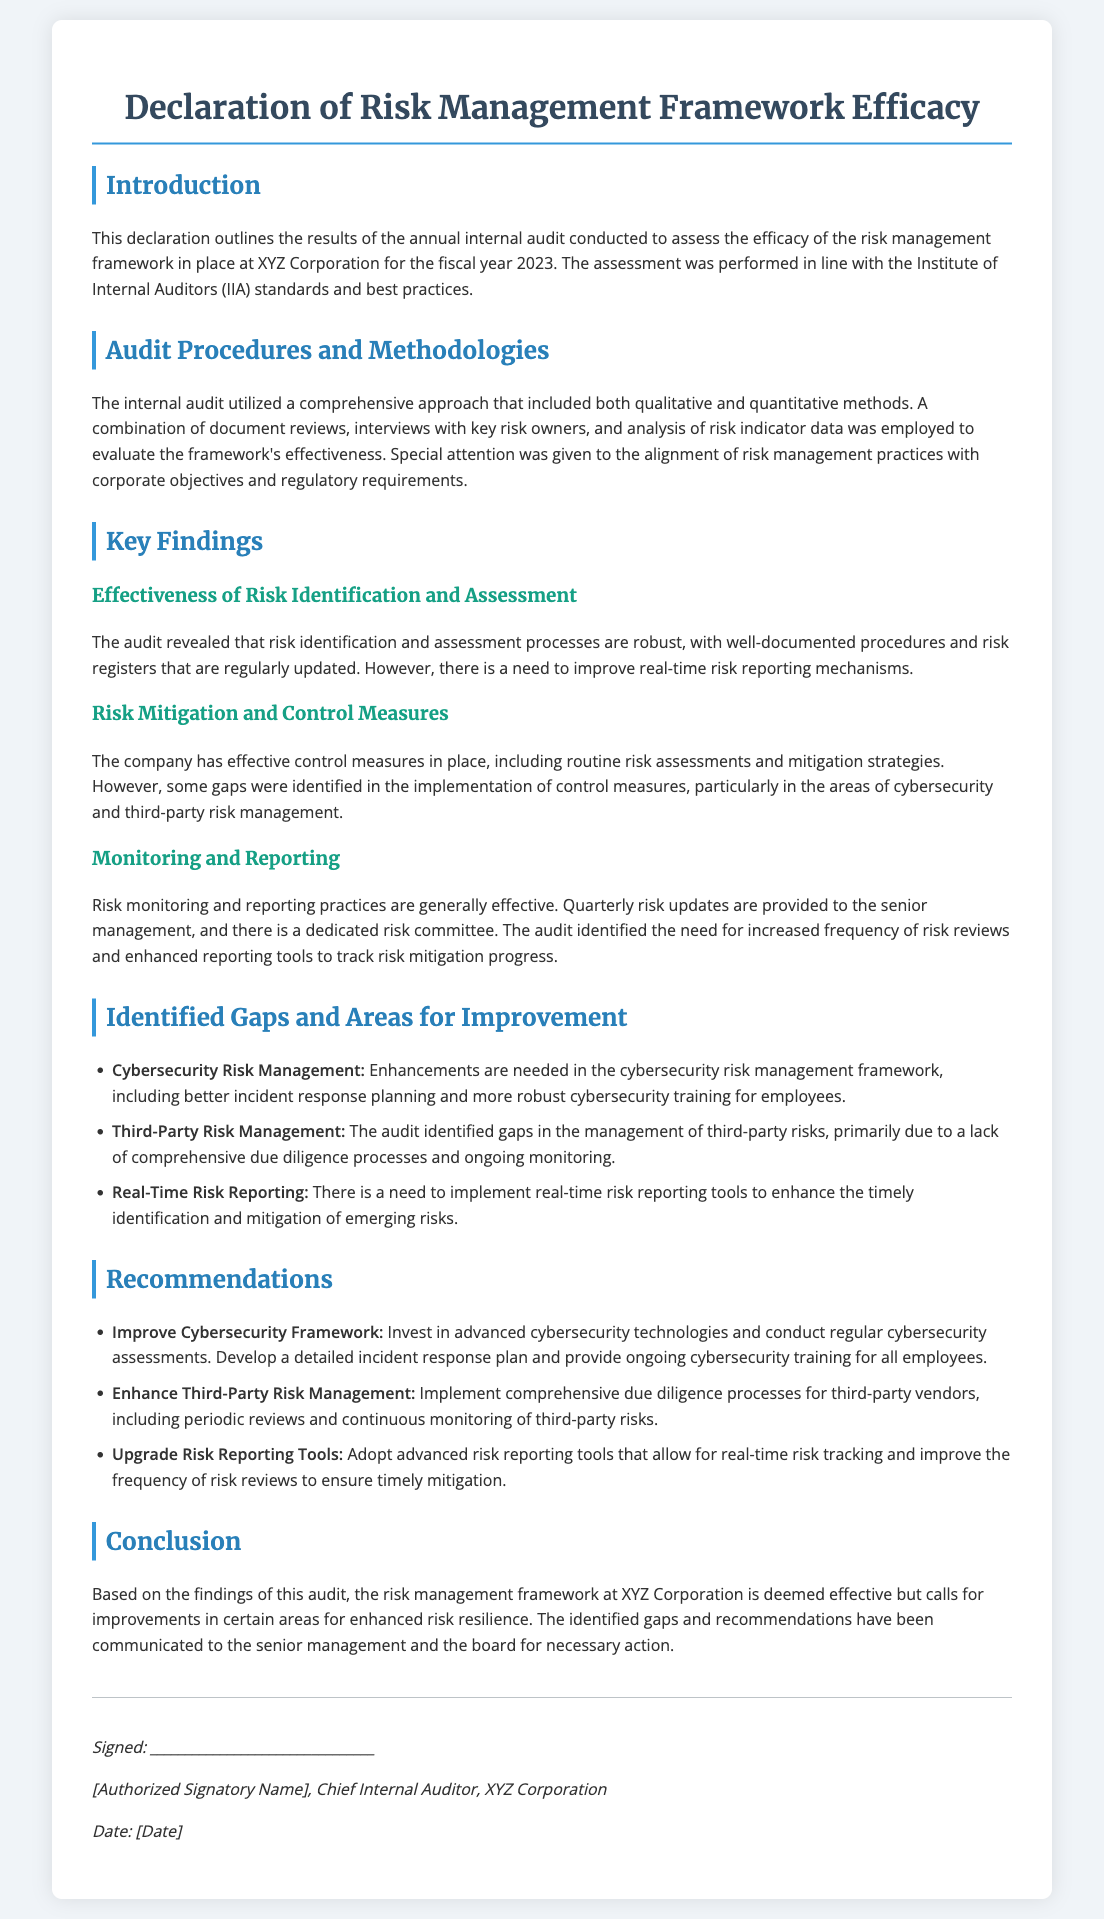What is the subject of the declaration? The declaration outlines the results of the annual internal audit conducted to assess the efficacy of the risk management framework at XYZ Corporation for the fiscal year 2023.
Answer: Risk Management Framework Efficacy Who performed the internal audit? The internal audit was conducted by the Chief Internal Auditor at XYZ Corporation.
Answer: Chief Internal Auditor What year was the assessment conducted? The assessment was performed for the fiscal year specified in the declaration.
Answer: 2023 What areas require improvement according to the findings? The findings identified several areas for improvement including cybersecurity, third-party risk management, and real-time risk reporting.
Answer: Cybersecurity, Third-Party Risk Management, Real-Time Risk Reporting What is one recommendation made for third-party risk management? The audit recommends implementing comprehensive due diligence processes for third-party vendors.
Answer: Comprehensive due diligence processes How are risk updates communicated to senior management? Quarterly risk updates are provided to senior management as part of the monitoring process.
Answer: Quarterly risk updates What is the focus of the audit methodologies used? The methodologies focused on both qualitative and quantitative evaluation methods.
Answer: Qualitative and quantitative methods What is the primary purpose of this declaration? The declaration serves to communicate the findings and recommendations of the internal audit regarding risk management practices.
Answer: Communicate findings and recommendations When was the document signed? The exact signing date is indicated in the footer of the document.
Answer: [Date] 